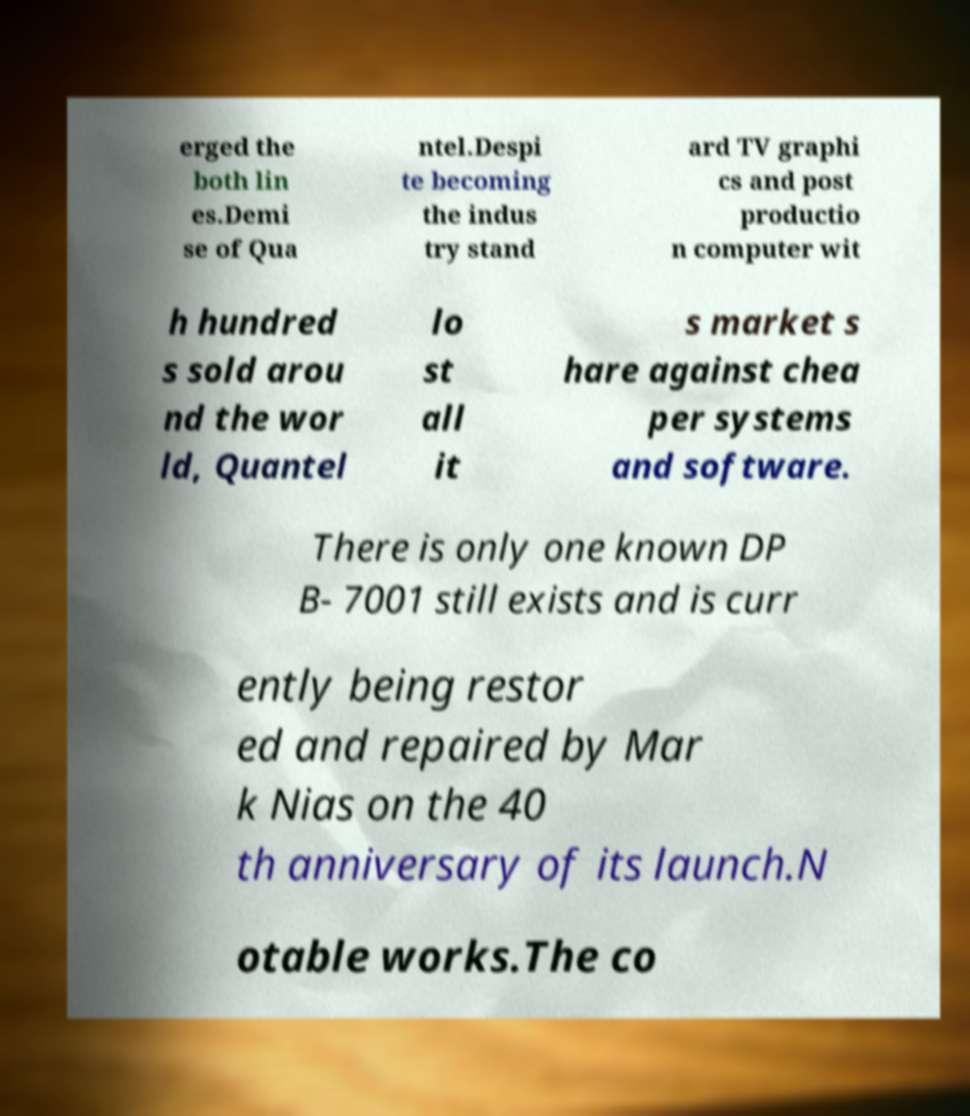Can you accurately transcribe the text from the provided image for me? erged the both lin es.Demi se of Qua ntel.Despi te becoming the indus try stand ard TV graphi cs and post productio n computer wit h hundred s sold arou nd the wor ld, Quantel lo st all it s market s hare against chea per systems and software. There is only one known DP B- 7001 still exists and is curr ently being restor ed and repaired by Mar k Nias on the 40 th anniversary of its launch.N otable works.The co 